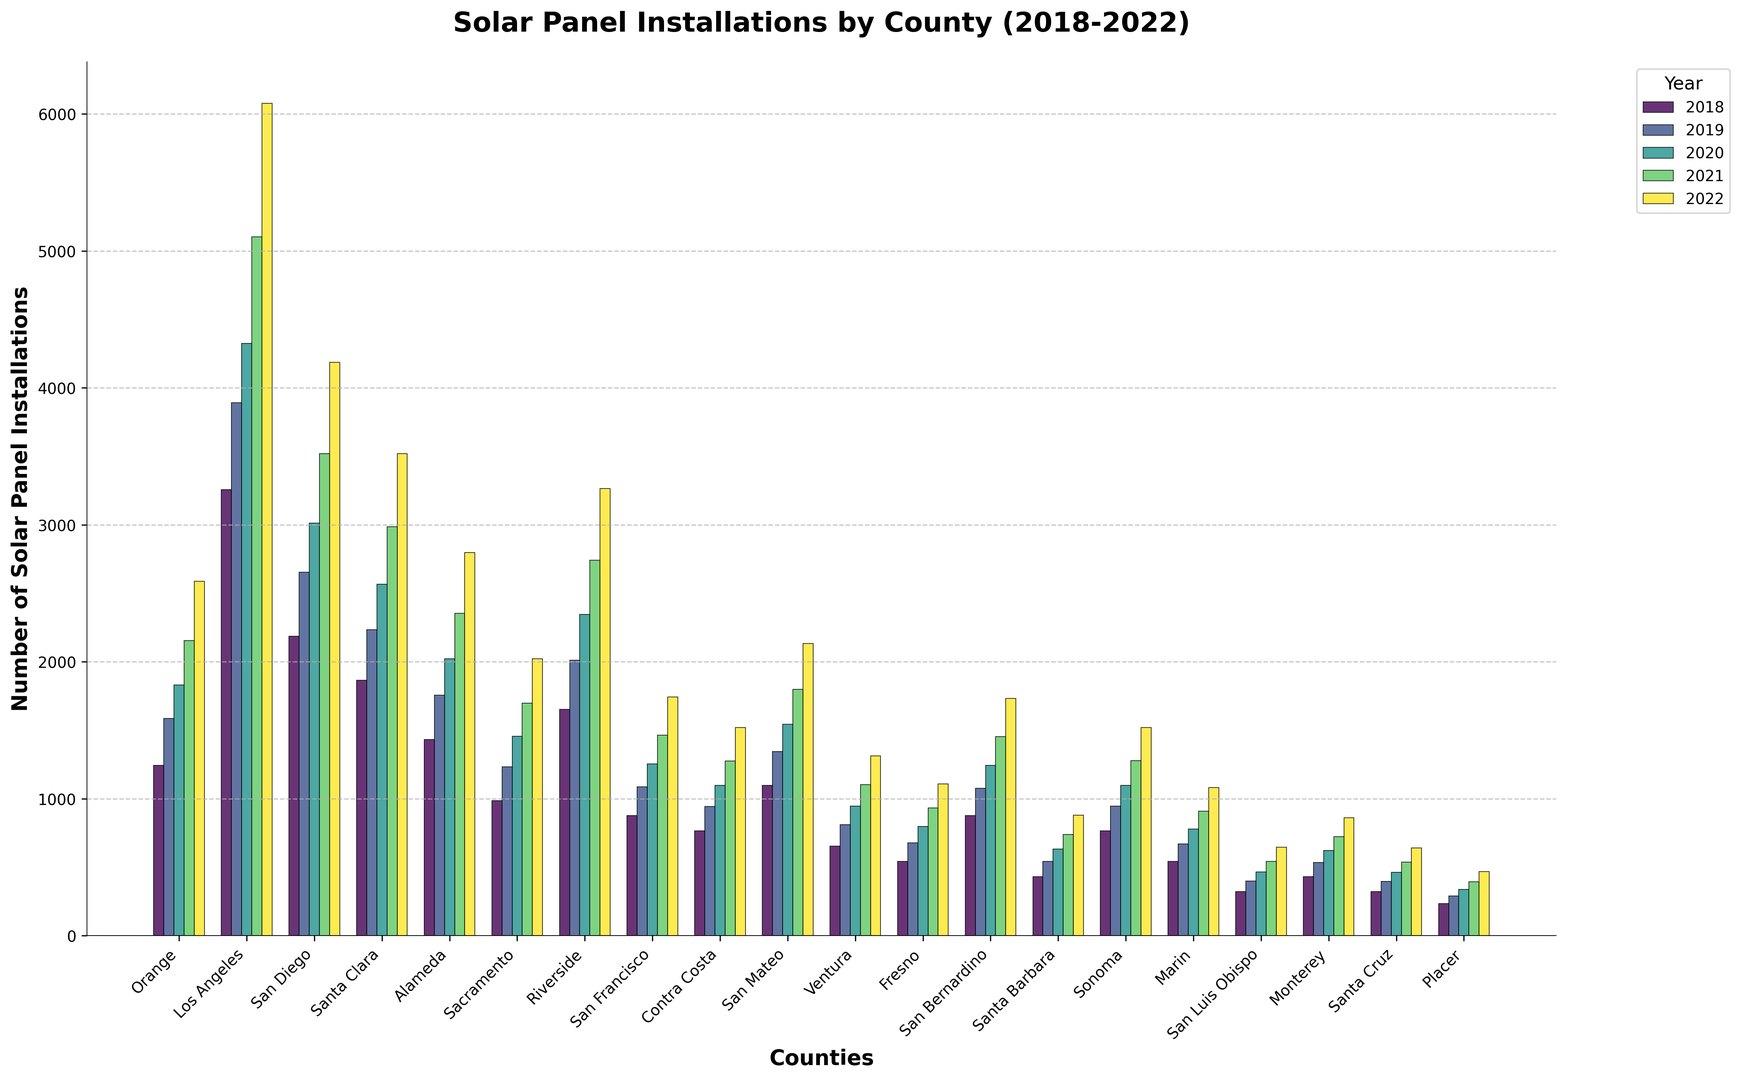What is the county with the highest number of solar panel installations in 2022? To find the county with the highest number of solar panel installations in 2022, look for the tallest bar in the 2022 color for each county. Los Angeles has the tallest bar in 2022.
Answer: Los Angeles Which counties had more than 2000 solar panel installations in 2021? To find which counties had more than 2000 installations in 2021, look for all bars in the 2021 category that exceed the value of 2000 on the y-axis. Orange, Los Angeles, San Diego, Santa Clara, Alameda, and Riverside had more than 2000 solar panel installations in 2021.
Answer: Orange, Los Angeles, San Diego, Santa Clara, Alameda, Riverside What is the average number of solar panel installations in San Francisco over the 5 years? Sum the number of installations in San Francisco for each year (876+1087+1254+1465+1743) and divide by 5: (876 + 1087 + 1254 + 1465 + 1743) / 5 = 6425 / 5 = 1285
Answer: 1285 Which year showed the most significant growth in solar panel installations in Riverside? To determine the most significant growth year in Riverside, calculate the difference in installations between each pair of consecutive years and find the maximum. 2019-2018: 2012-1654 = 358, 2020-2019: 2345-2012 = 333, 2021-2020: 2743-2345 = 398, 2022-2021: 3265-2743 = 522. The highest difference is between 2021-2022.
Answer: 2022 Compare the growth in solar panel installations between San Diego and Santa Clara from 2018 to 2022. Which county had higher growth? To find this, calculate the increase from 2018 to 2022 for both counties. San Diego: 4187-2187 = 2000, Santa Clara: 3521-1865 = 1656. San Diego had higher growth.
Answer: San Diego Which county had the least number of solar panel installations in 2020? To determine the county with the least number of installations in 2020, look for the shortest bar in the 2020 category. Placer had the shortest bar in 2020.
Answer: Placer How many counties had less than 1000 solar panel installations in 2018? To find this, count all the counties whose 2018 bar is below the 1000 mark on the y-axis: Sacramento, San Francisco, Contra Costa, Ventura, Fresno, Santa Barbara, Sonoma, Marin, San Luis Obispo, Monterey, Santa Cruz, Placer (12 counties).
Answer: 12 What is the total number of solar panel installations in Alameda over all 5 years? Sum the number of installations in Alameda for each year (1432 + 1756 + 2021 + 2354 + 2798). 1432 + 1756 + 2021 + 2354 + 2798 = 10361
Answer: 10361 